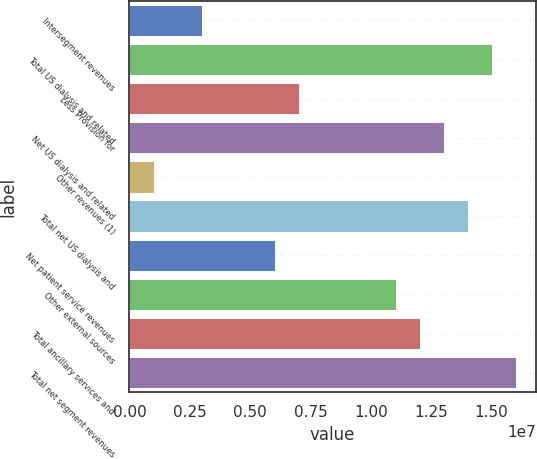Convert chart to OTSL. <chart><loc_0><loc_0><loc_500><loc_500><bar_chart><fcel>Intersegment revenues<fcel>Total US dialysis and related<fcel>Less Provision for<fcel>Net US dialysis and related<fcel>Other revenues (1)<fcel>Total net US dialysis and<fcel>Net patient service revenues<fcel>Other external sources<fcel>Total ancillary services and<fcel>Total net segment revenues<nl><fcel>3.01281e+06<fcel>1.50318e+07<fcel>7.01913e+06<fcel>1.30286e+07<fcel>1.00965e+06<fcel>1.40302e+07<fcel>6.01755e+06<fcel>1.10254e+07<fcel>1.2027e+07<fcel>1.60333e+07<nl></chart> 